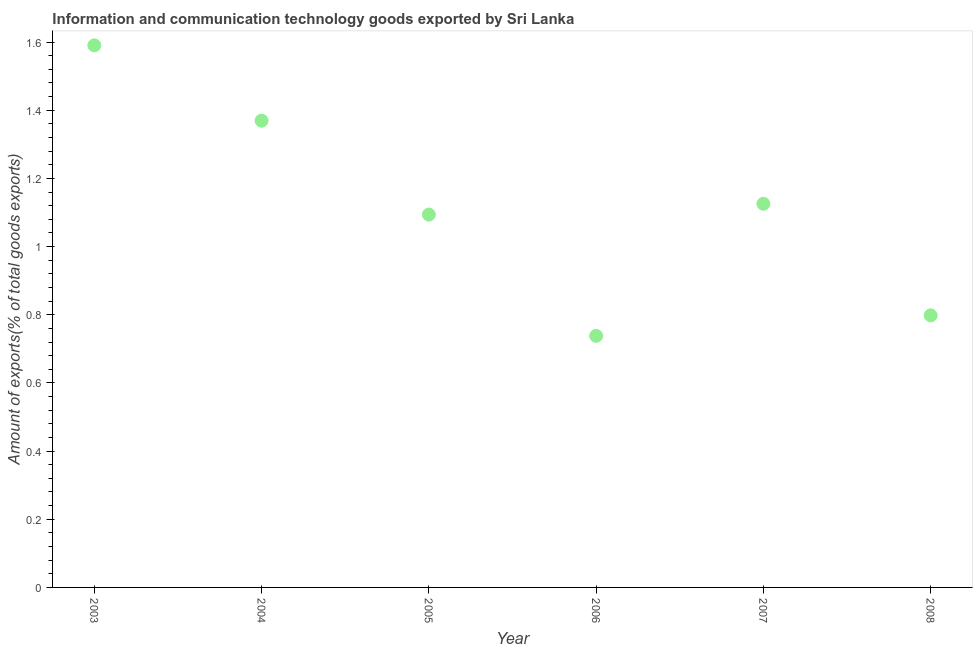What is the amount of ict goods exports in 2006?
Provide a succinct answer. 0.74. Across all years, what is the maximum amount of ict goods exports?
Your answer should be compact. 1.59. Across all years, what is the minimum amount of ict goods exports?
Provide a succinct answer. 0.74. In which year was the amount of ict goods exports minimum?
Make the answer very short. 2006. What is the sum of the amount of ict goods exports?
Give a very brief answer. 6.72. What is the difference between the amount of ict goods exports in 2006 and 2007?
Give a very brief answer. -0.39. What is the average amount of ict goods exports per year?
Offer a very short reply. 1.12. What is the median amount of ict goods exports?
Your answer should be compact. 1.11. In how many years, is the amount of ict goods exports greater than 1.2800000000000002 %?
Offer a terse response. 2. What is the ratio of the amount of ict goods exports in 2004 to that in 2006?
Make the answer very short. 1.86. What is the difference between the highest and the second highest amount of ict goods exports?
Offer a very short reply. 0.22. Is the sum of the amount of ict goods exports in 2007 and 2008 greater than the maximum amount of ict goods exports across all years?
Give a very brief answer. Yes. What is the difference between the highest and the lowest amount of ict goods exports?
Offer a terse response. 0.85. Does the amount of ict goods exports monotonically increase over the years?
Provide a short and direct response. No. How many dotlines are there?
Provide a succinct answer. 1. What is the difference between two consecutive major ticks on the Y-axis?
Offer a terse response. 0.2. Are the values on the major ticks of Y-axis written in scientific E-notation?
Make the answer very short. No. Does the graph contain any zero values?
Give a very brief answer. No. What is the title of the graph?
Make the answer very short. Information and communication technology goods exported by Sri Lanka. What is the label or title of the Y-axis?
Ensure brevity in your answer.  Amount of exports(% of total goods exports). What is the Amount of exports(% of total goods exports) in 2003?
Provide a succinct answer. 1.59. What is the Amount of exports(% of total goods exports) in 2004?
Make the answer very short. 1.37. What is the Amount of exports(% of total goods exports) in 2005?
Your answer should be very brief. 1.09. What is the Amount of exports(% of total goods exports) in 2006?
Your response must be concise. 0.74. What is the Amount of exports(% of total goods exports) in 2007?
Your response must be concise. 1.13. What is the Amount of exports(% of total goods exports) in 2008?
Make the answer very short. 0.8. What is the difference between the Amount of exports(% of total goods exports) in 2003 and 2004?
Provide a succinct answer. 0.22. What is the difference between the Amount of exports(% of total goods exports) in 2003 and 2005?
Provide a succinct answer. 0.5. What is the difference between the Amount of exports(% of total goods exports) in 2003 and 2006?
Your answer should be compact. 0.85. What is the difference between the Amount of exports(% of total goods exports) in 2003 and 2007?
Provide a succinct answer. 0.46. What is the difference between the Amount of exports(% of total goods exports) in 2003 and 2008?
Your response must be concise. 0.79. What is the difference between the Amount of exports(% of total goods exports) in 2004 and 2005?
Give a very brief answer. 0.28. What is the difference between the Amount of exports(% of total goods exports) in 2004 and 2006?
Offer a very short reply. 0.63. What is the difference between the Amount of exports(% of total goods exports) in 2004 and 2007?
Ensure brevity in your answer.  0.24. What is the difference between the Amount of exports(% of total goods exports) in 2004 and 2008?
Your answer should be very brief. 0.57. What is the difference between the Amount of exports(% of total goods exports) in 2005 and 2006?
Your answer should be compact. 0.36. What is the difference between the Amount of exports(% of total goods exports) in 2005 and 2007?
Your answer should be very brief. -0.03. What is the difference between the Amount of exports(% of total goods exports) in 2005 and 2008?
Provide a short and direct response. 0.3. What is the difference between the Amount of exports(% of total goods exports) in 2006 and 2007?
Keep it short and to the point. -0.39. What is the difference between the Amount of exports(% of total goods exports) in 2006 and 2008?
Provide a succinct answer. -0.06. What is the difference between the Amount of exports(% of total goods exports) in 2007 and 2008?
Keep it short and to the point. 0.33. What is the ratio of the Amount of exports(% of total goods exports) in 2003 to that in 2004?
Your answer should be compact. 1.16. What is the ratio of the Amount of exports(% of total goods exports) in 2003 to that in 2005?
Your answer should be compact. 1.45. What is the ratio of the Amount of exports(% of total goods exports) in 2003 to that in 2006?
Provide a short and direct response. 2.15. What is the ratio of the Amount of exports(% of total goods exports) in 2003 to that in 2007?
Your response must be concise. 1.41. What is the ratio of the Amount of exports(% of total goods exports) in 2003 to that in 2008?
Ensure brevity in your answer.  1.99. What is the ratio of the Amount of exports(% of total goods exports) in 2004 to that in 2005?
Your response must be concise. 1.25. What is the ratio of the Amount of exports(% of total goods exports) in 2004 to that in 2006?
Give a very brief answer. 1.85. What is the ratio of the Amount of exports(% of total goods exports) in 2004 to that in 2007?
Make the answer very short. 1.22. What is the ratio of the Amount of exports(% of total goods exports) in 2004 to that in 2008?
Offer a terse response. 1.72. What is the ratio of the Amount of exports(% of total goods exports) in 2005 to that in 2006?
Your answer should be compact. 1.48. What is the ratio of the Amount of exports(% of total goods exports) in 2005 to that in 2008?
Your response must be concise. 1.37. What is the ratio of the Amount of exports(% of total goods exports) in 2006 to that in 2007?
Offer a terse response. 0.66. What is the ratio of the Amount of exports(% of total goods exports) in 2006 to that in 2008?
Your answer should be very brief. 0.93. What is the ratio of the Amount of exports(% of total goods exports) in 2007 to that in 2008?
Ensure brevity in your answer.  1.41. 